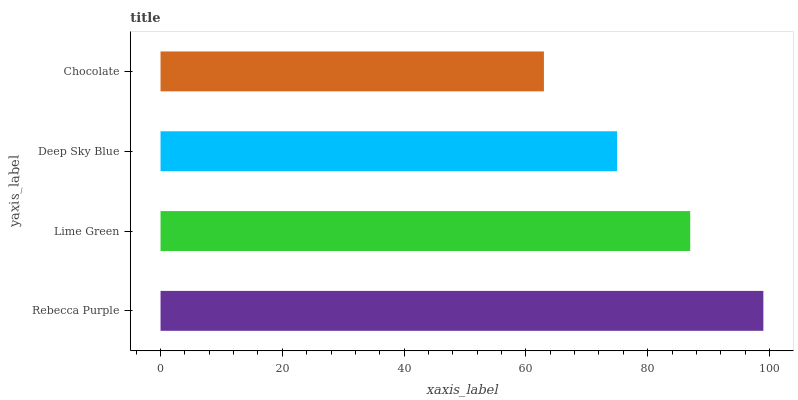Is Chocolate the minimum?
Answer yes or no. Yes. Is Rebecca Purple the maximum?
Answer yes or no. Yes. Is Lime Green the minimum?
Answer yes or no. No. Is Lime Green the maximum?
Answer yes or no. No. Is Rebecca Purple greater than Lime Green?
Answer yes or no. Yes. Is Lime Green less than Rebecca Purple?
Answer yes or no. Yes. Is Lime Green greater than Rebecca Purple?
Answer yes or no. No. Is Rebecca Purple less than Lime Green?
Answer yes or no. No. Is Lime Green the high median?
Answer yes or no. Yes. Is Deep Sky Blue the low median?
Answer yes or no. Yes. Is Chocolate the high median?
Answer yes or no. No. Is Chocolate the low median?
Answer yes or no. No. 